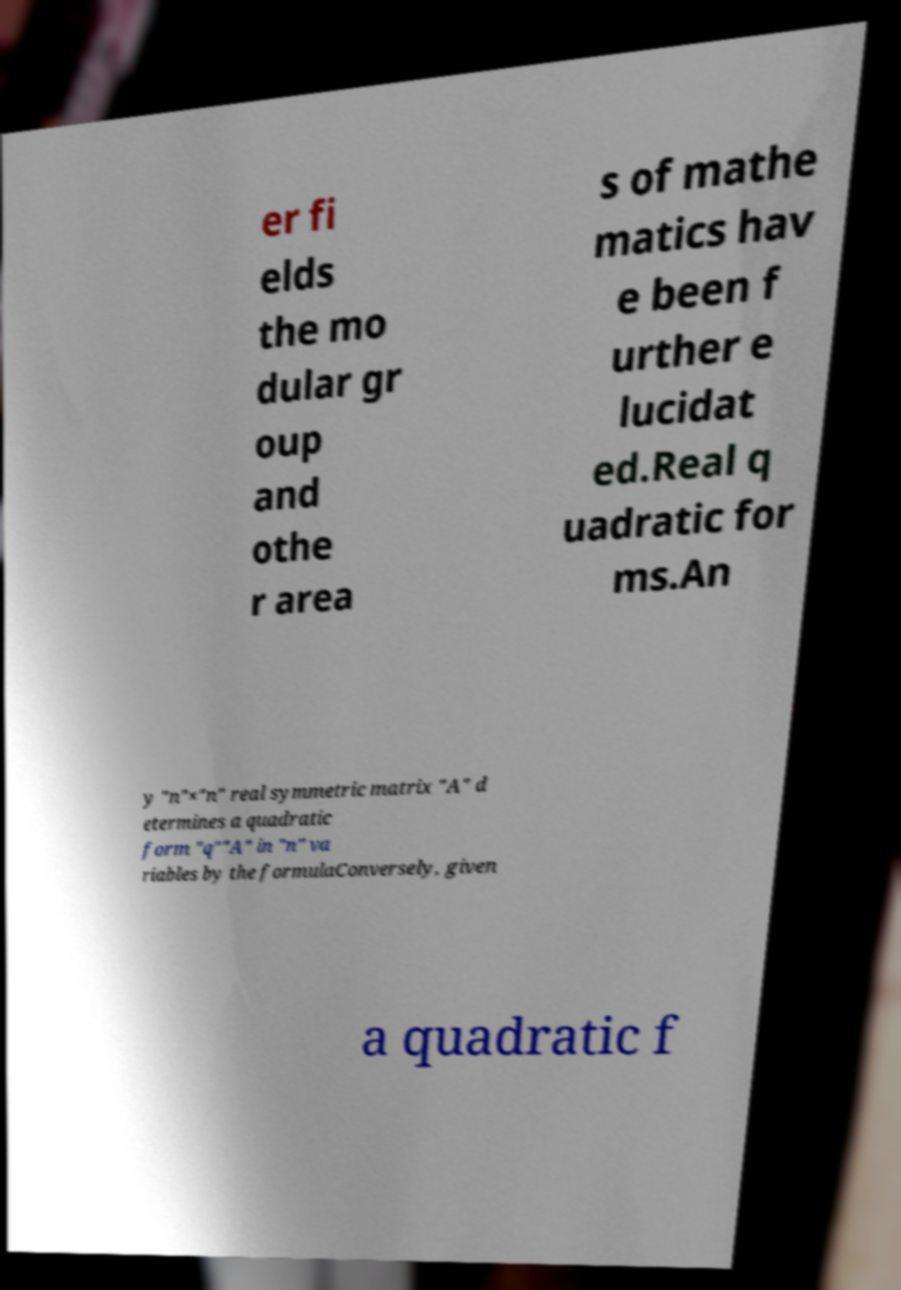Could you extract and type out the text from this image? er fi elds the mo dular gr oup and othe r area s of mathe matics hav e been f urther e lucidat ed.Real q uadratic for ms.An y "n"×"n" real symmetric matrix "A" d etermines a quadratic form "q""A" in "n" va riables by the formulaConversely, given a quadratic f 